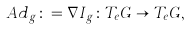Convert formula to latex. <formula><loc_0><loc_0><loc_500><loc_500>A d _ { g } \colon = \nabla I _ { g } \colon T _ { e } G \rightarrow T _ { e } G ,</formula> 